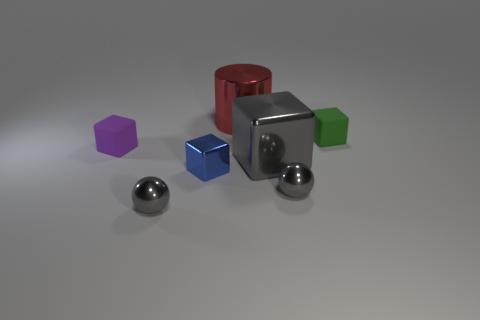Add 3 tiny blue shiny things. How many objects exist? 10 Subtract all blocks. How many objects are left? 3 Add 4 purple objects. How many purple objects exist? 5 Subtract 1 gray blocks. How many objects are left? 6 Subtract all small green rubber things. Subtract all small green rubber objects. How many objects are left? 5 Add 4 large shiny cylinders. How many large shiny cylinders are left? 5 